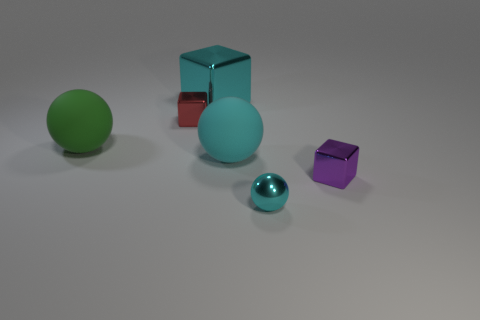Add 4 large cyan matte cubes. How many objects exist? 10 Subtract 1 cyan cubes. How many objects are left? 5 Subtract all big green matte things. Subtract all tiny cyan metallic spheres. How many objects are left? 4 Add 1 matte balls. How many matte balls are left? 3 Add 2 big blue metallic blocks. How many big blue metallic blocks exist? 2 